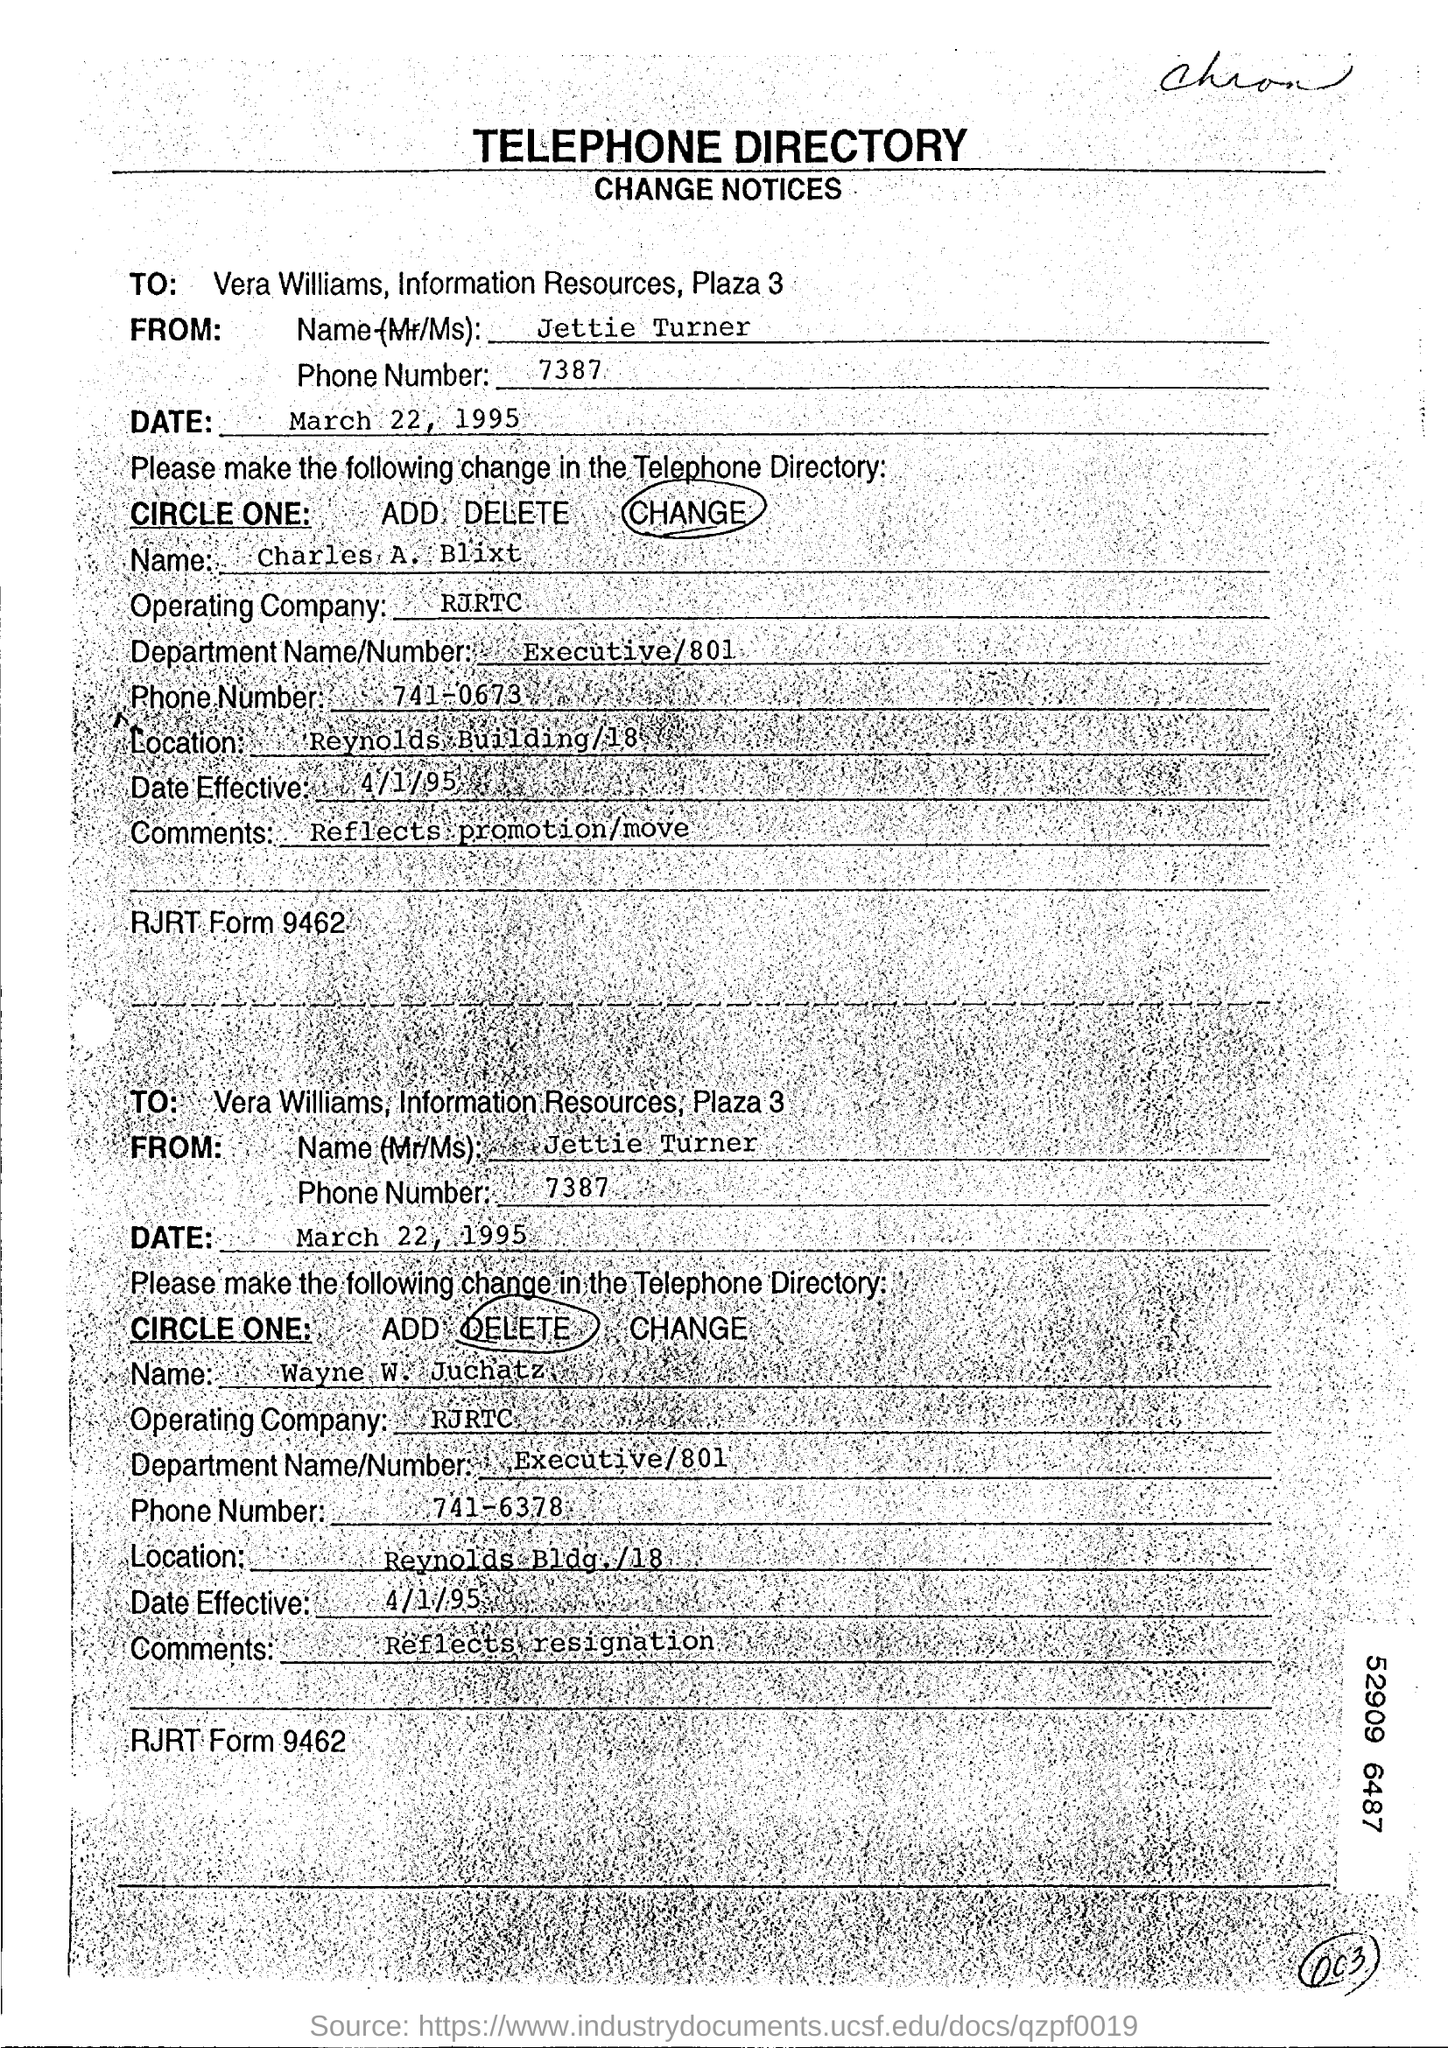Point out several critical features in this image. RJRTC is the operating company. The date is March 22, 1995. The location is the Reynolds Building at 18... The effective date of the document is April 1, 1995. The document is addressed to Vera Williams, Information Resources, at Plaza 3. 